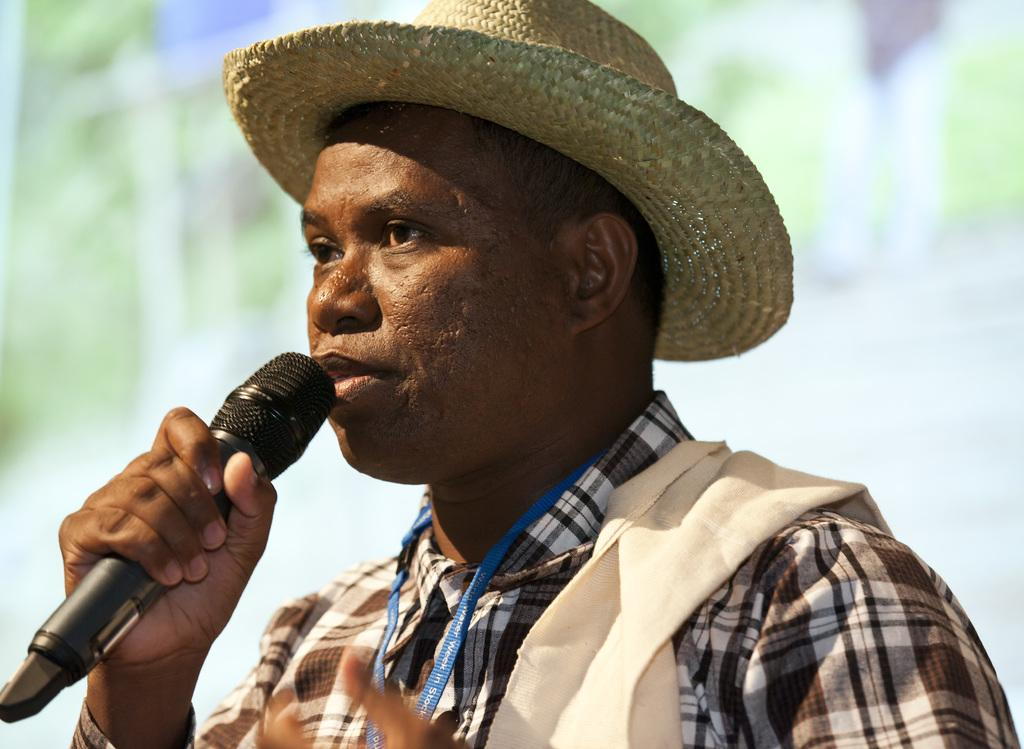What is the man in the image holding? The man is holding a mic in the image. Can you describe the man's attire in the image? The man is wearing a hat on his head in the image. What type of jelly is the man eating in the image? There is no jelly present in the image. What is the man's son doing in the image? There is no son present in the image. What type of coat is the man wearing in the image? The provided facts do not mention a coat, so we cannot determine if the man is wearing a coat in the image. 